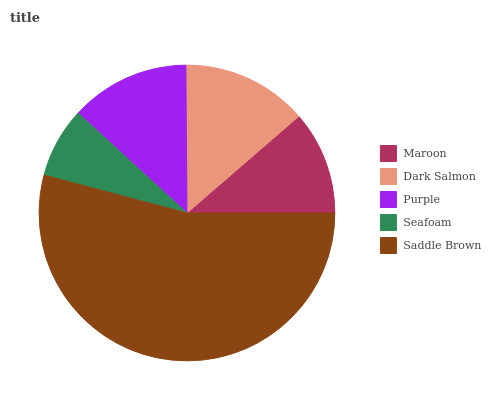Is Seafoam the minimum?
Answer yes or no. Yes. Is Saddle Brown the maximum?
Answer yes or no. Yes. Is Dark Salmon the minimum?
Answer yes or no. No. Is Dark Salmon the maximum?
Answer yes or no. No. Is Dark Salmon greater than Maroon?
Answer yes or no. Yes. Is Maroon less than Dark Salmon?
Answer yes or no. Yes. Is Maroon greater than Dark Salmon?
Answer yes or no. No. Is Dark Salmon less than Maroon?
Answer yes or no. No. Is Purple the high median?
Answer yes or no. Yes. Is Purple the low median?
Answer yes or no. Yes. Is Saddle Brown the high median?
Answer yes or no. No. Is Seafoam the low median?
Answer yes or no. No. 